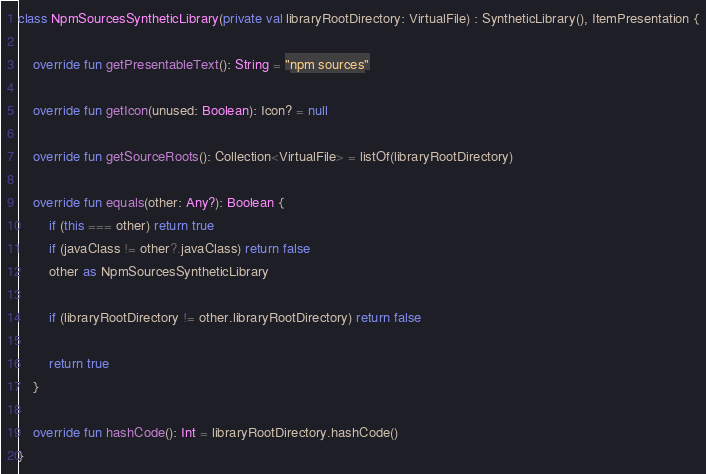Convert code to text. <code><loc_0><loc_0><loc_500><loc_500><_Kotlin_>class NpmSourcesSyntheticLibrary(private val libraryRootDirectory: VirtualFile) : SyntheticLibrary(), ItemPresentation {

    override fun getPresentableText(): String = "npm sources"

    override fun getIcon(unused: Boolean): Icon? = null

    override fun getSourceRoots(): Collection<VirtualFile> = listOf(libraryRootDirectory)

    override fun equals(other: Any?): Boolean {
        if (this === other) return true
        if (javaClass != other?.javaClass) return false
        other as NpmSourcesSyntheticLibrary

        if (libraryRootDirectory != other.libraryRootDirectory) return false

        return true
    }

    override fun hashCode(): Int = libraryRootDirectory.hashCode()
}

</code> 